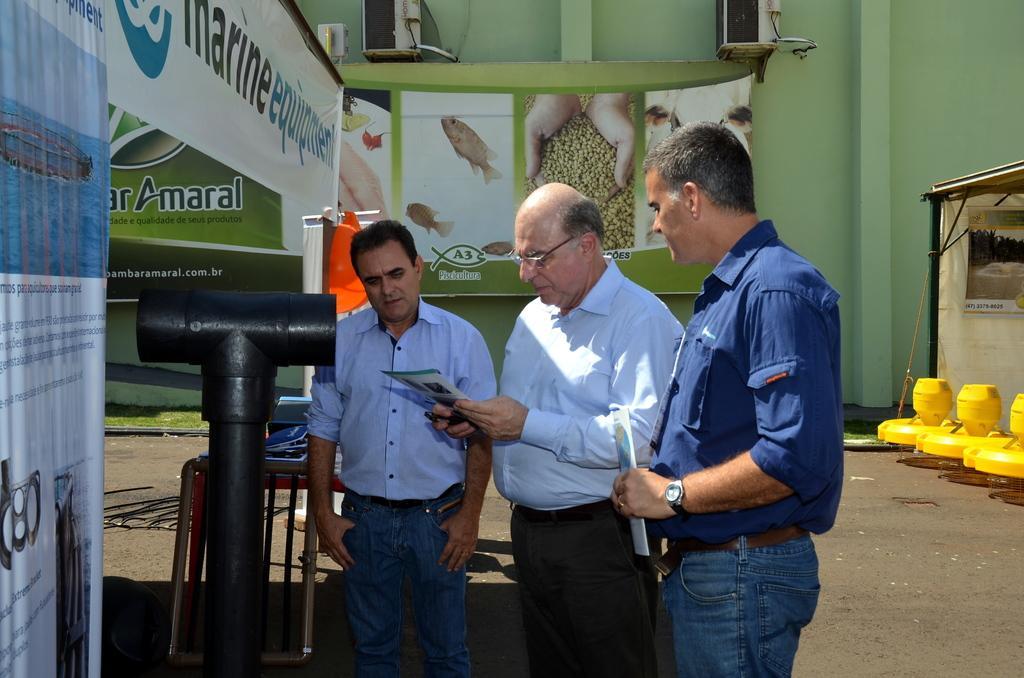Describe this image in one or two sentences. In this image we can see three persons and few people are holding some objects in their hands. There are few advertising boards and banners in the image. There is a tent at the right side of the image. There are few object at the right side of the image. There is a grassy land in the image. There are few objects on the wall. 